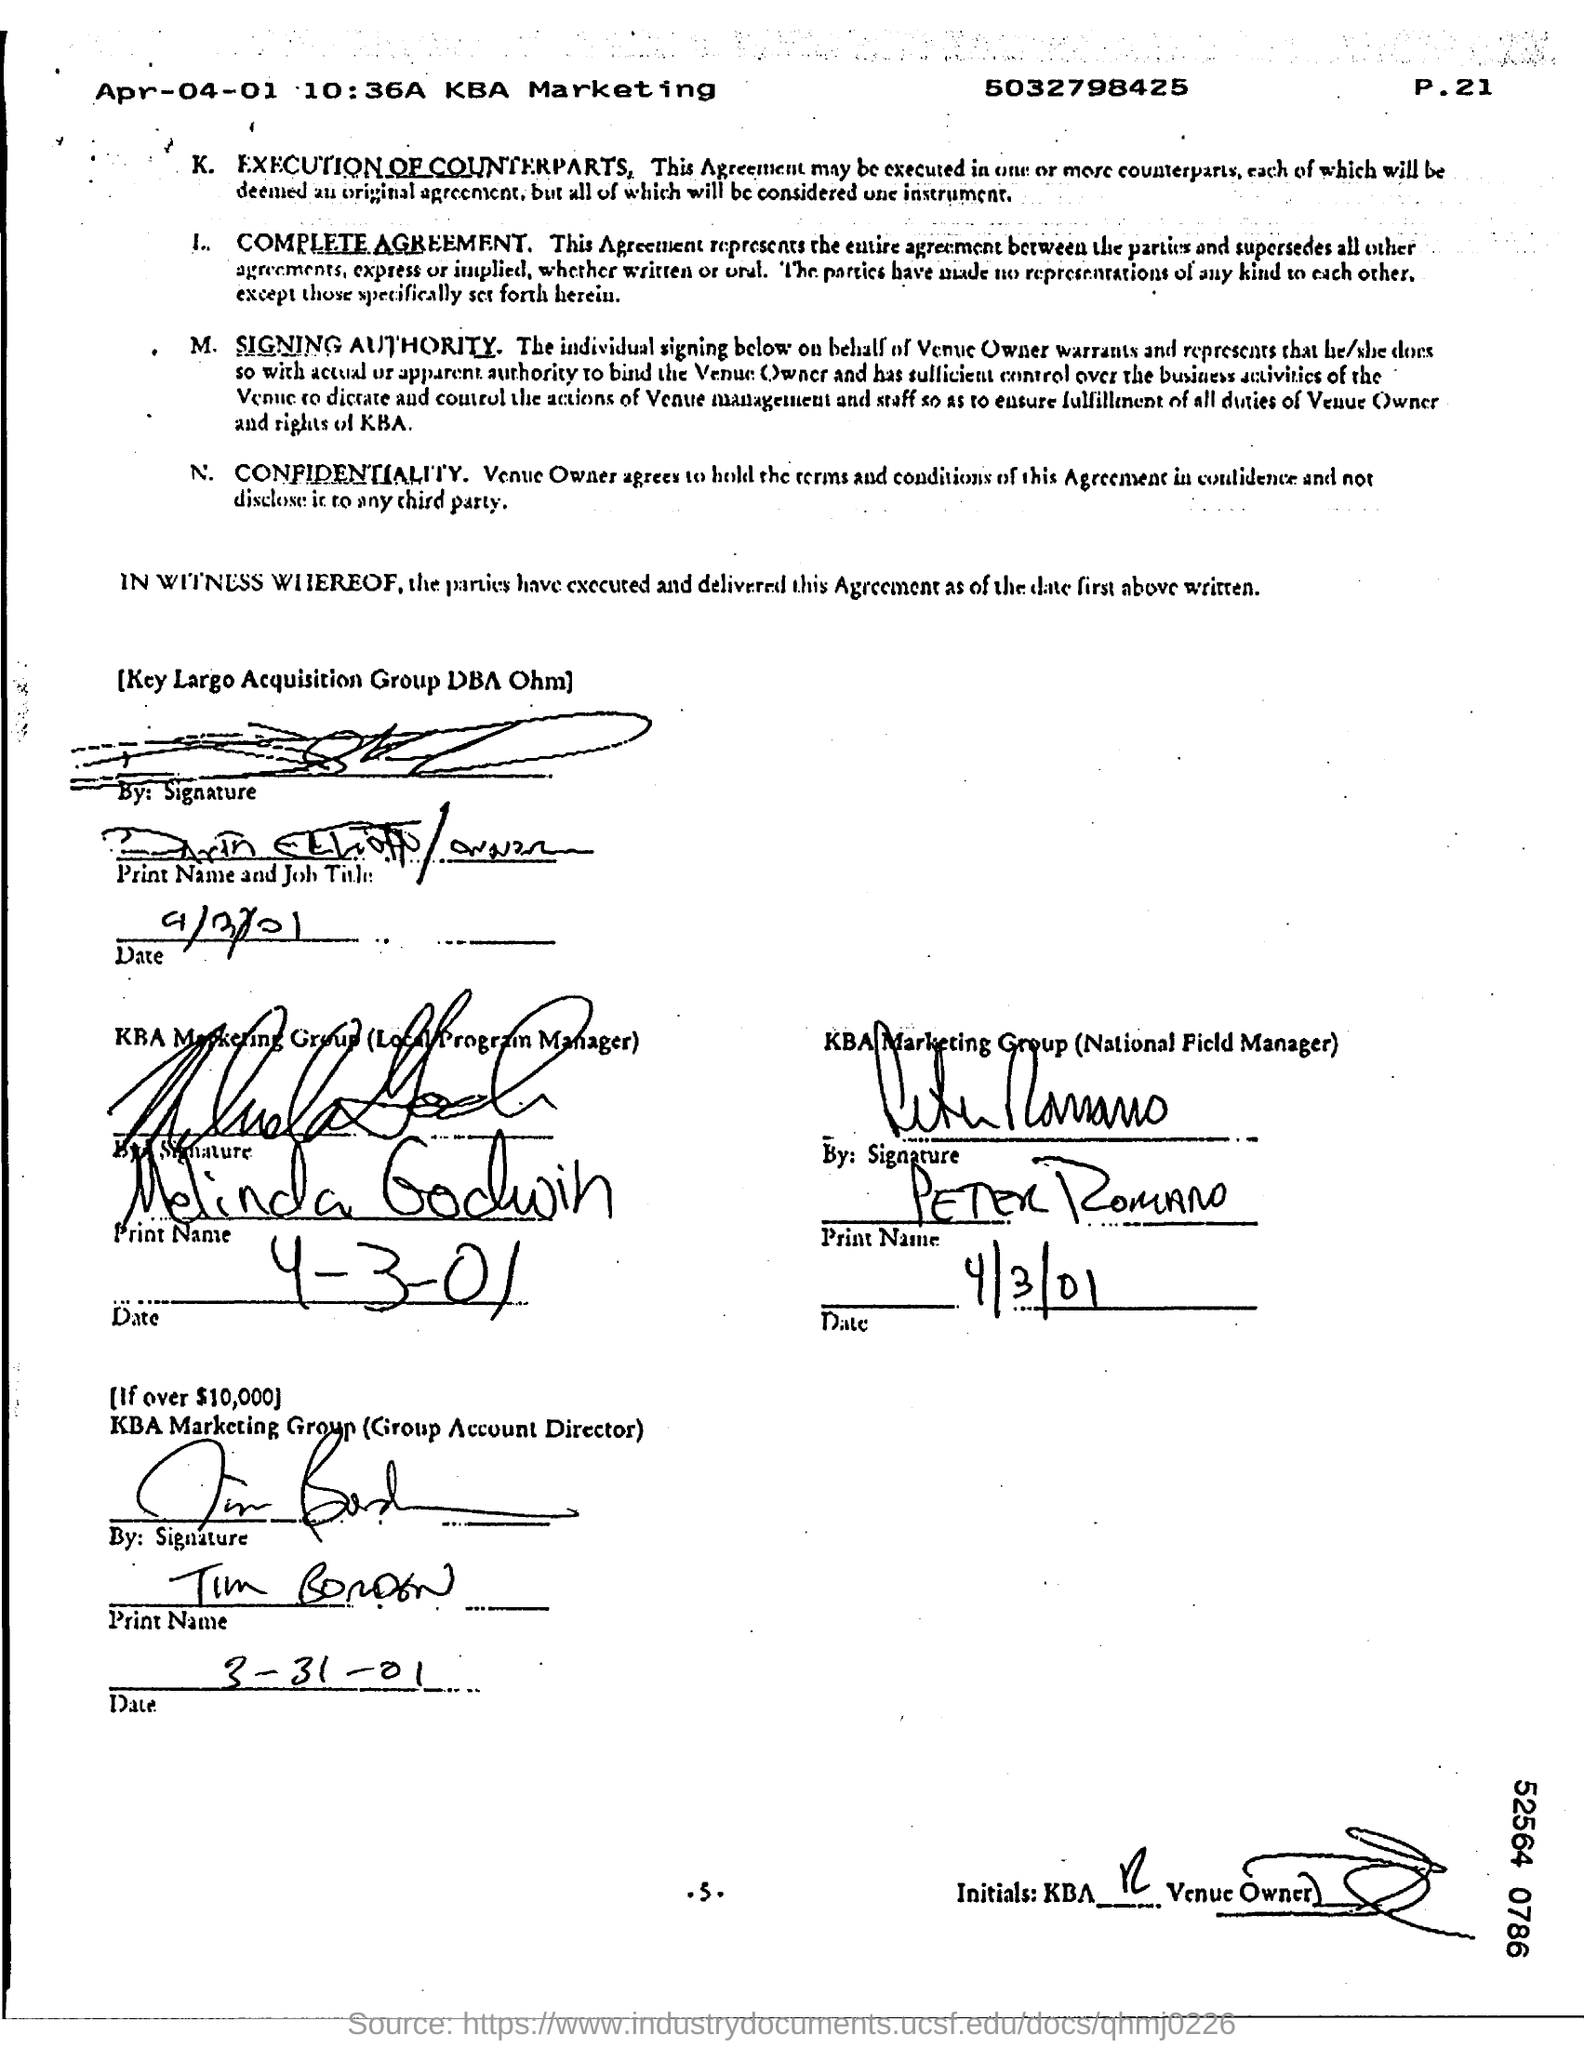When is the document dated?
Give a very brief answer. Apr-04-01. Who is the National Field Manager of KBA Marketing Group?
Your answer should be very brief. PETER ROMANO. What is Melinda Godwin's designation?
Your answer should be very brief. Local program manager. 